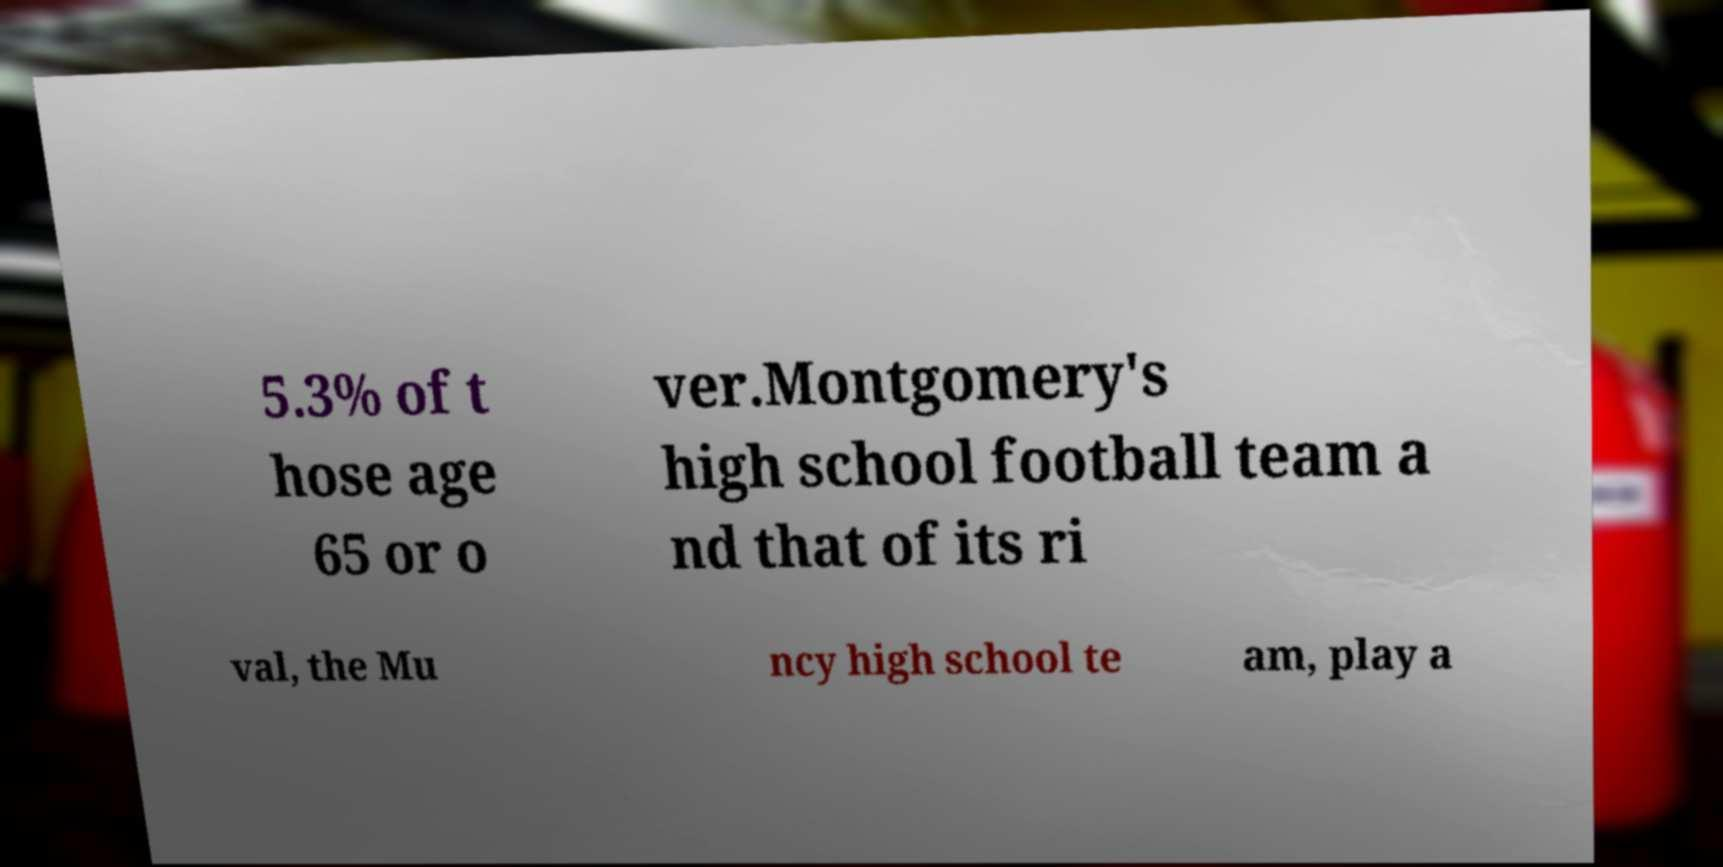Could you extract and type out the text from this image? 5.3% of t hose age 65 or o ver.Montgomery's high school football team a nd that of its ri val, the Mu ncy high school te am, play a 